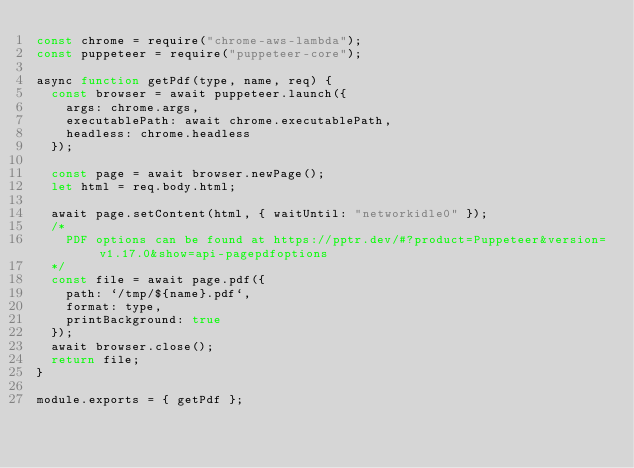<code> <loc_0><loc_0><loc_500><loc_500><_JavaScript_>const chrome = require("chrome-aws-lambda");
const puppeteer = require("puppeteer-core");

async function getPdf(type, name, req) {
  const browser = await puppeteer.launch({
    args: chrome.args,
    executablePath: await chrome.executablePath,
    headless: chrome.headless
  });

  const page = await browser.newPage();
  let html = req.body.html;

  await page.setContent(html, { waitUntil: "networkidle0" });
  /*
    PDF options can be found at https://pptr.dev/#?product=Puppeteer&version=v1.17.0&show=api-pagepdfoptions
  */
  const file = await page.pdf({
    path: `/tmp/${name}.pdf`,
    format: type,
    printBackground: true
  });
  await browser.close();
  return file;
}

module.exports = { getPdf };
</code> 